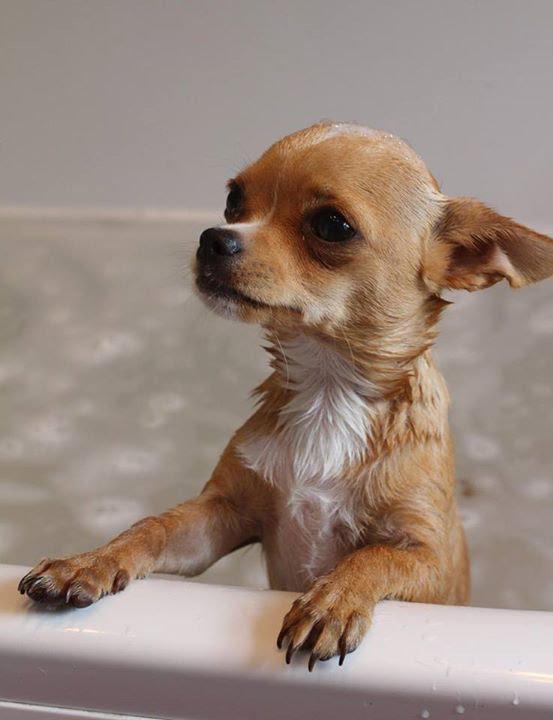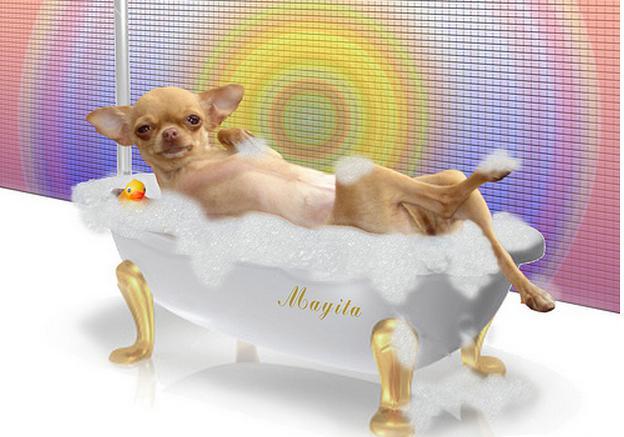The first image is the image on the left, the second image is the image on the right. Assess this claim about the two images: "One of the images shows a dog with bubbles on top of its head.". Correct or not? Answer yes or no. No. The first image is the image on the left, the second image is the image on the right. Assess this claim about the two images: "Both images show a small dog in contact with water.". Correct or not? Answer yes or no. Yes. 